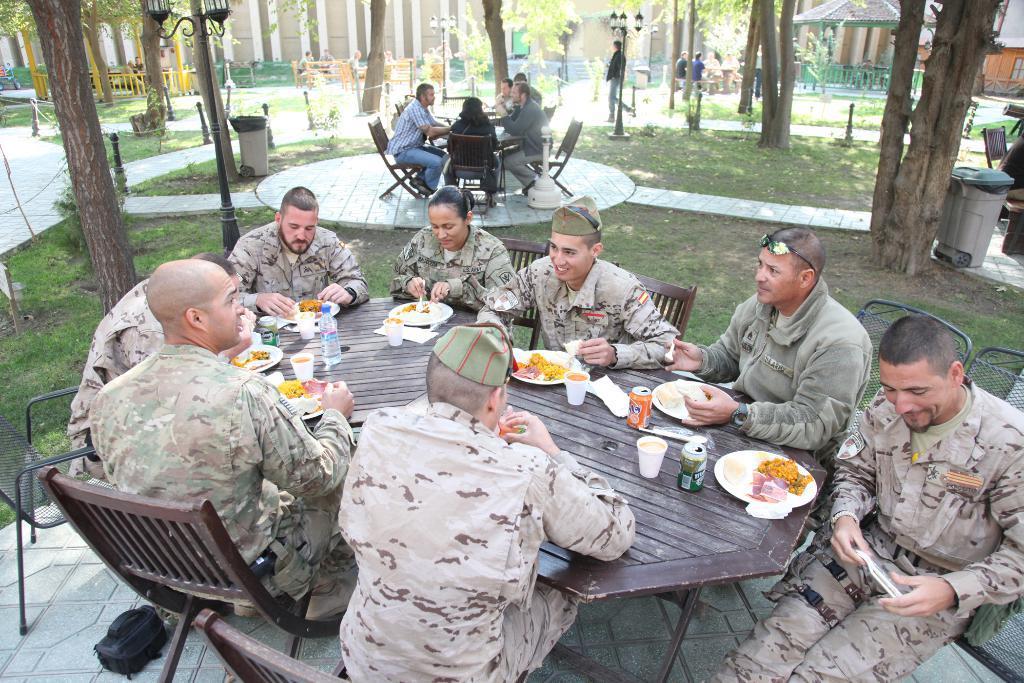Can you describe this image briefly? In this image there are many tables. On the table there are plates, bottles, cups, foods. Around the tables on the chairs people are sitting. Here there is a dustbin. in the background there are trees, fence,buildings,lights are there. 